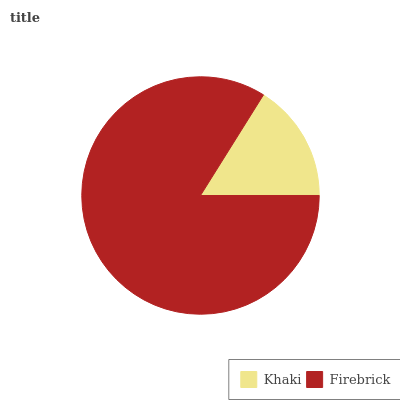Is Khaki the minimum?
Answer yes or no. Yes. Is Firebrick the maximum?
Answer yes or no. Yes. Is Firebrick the minimum?
Answer yes or no. No. Is Firebrick greater than Khaki?
Answer yes or no. Yes. Is Khaki less than Firebrick?
Answer yes or no. Yes. Is Khaki greater than Firebrick?
Answer yes or no. No. Is Firebrick less than Khaki?
Answer yes or no. No. Is Firebrick the high median?
Answer yes or no. Yes. Is Khaki the low median?
Answer yes or no. Yes. Is Khaki the high median?
Answer yes or no. No. Is Firebrick the low median?
Answer yes or no. No. 